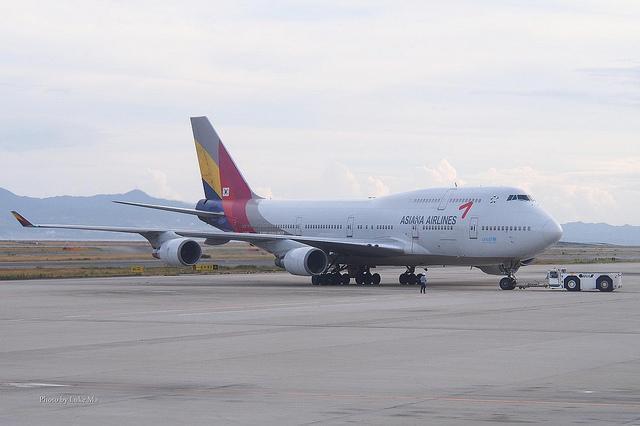How many planes at the runways?
Give a very brief answer. 1. How many cars are parked in this picture?
Give a very brief answer. 0. 